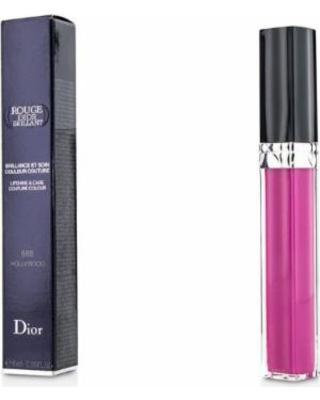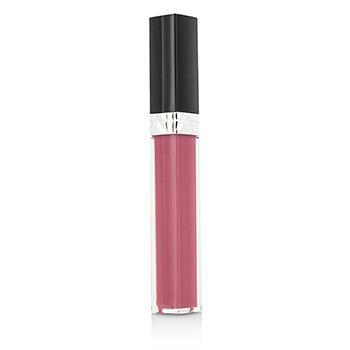The first image is the image on the left, the second image is the image on the right. For the images displayed, is the sentence "In each picture, there is one lip gloss tube with a black lid and no label." factually correct? Answer yes or no. Yes. The first image is the image on the left, the second image is the image on the right. Considering the images on both sides, is "There is at least one lip gloss applicator out of the tube." valid? Answer yes or no. No. 